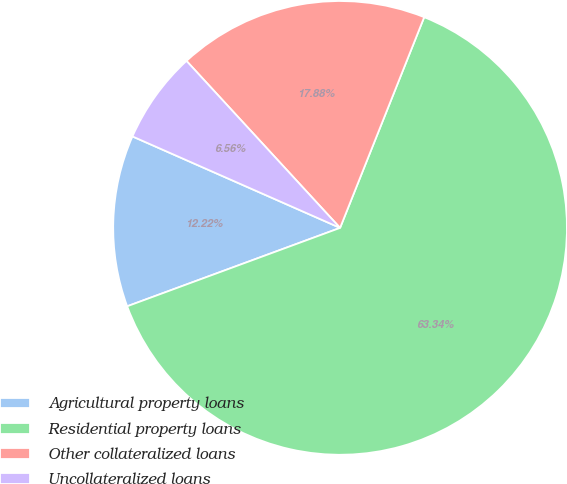Convert chart. <chart><loc_0><loc_0><loc_500><loc_500><pie_chart><fcel>Agricultural property loans<fcel>Residential property loans<fcel>Other collateralized loans<fcel>Uncollateralized loans<nl><fcel>12.22%<fcel>63.34%<fcel>17.88%<fcel>6.56%<nl></chart> 